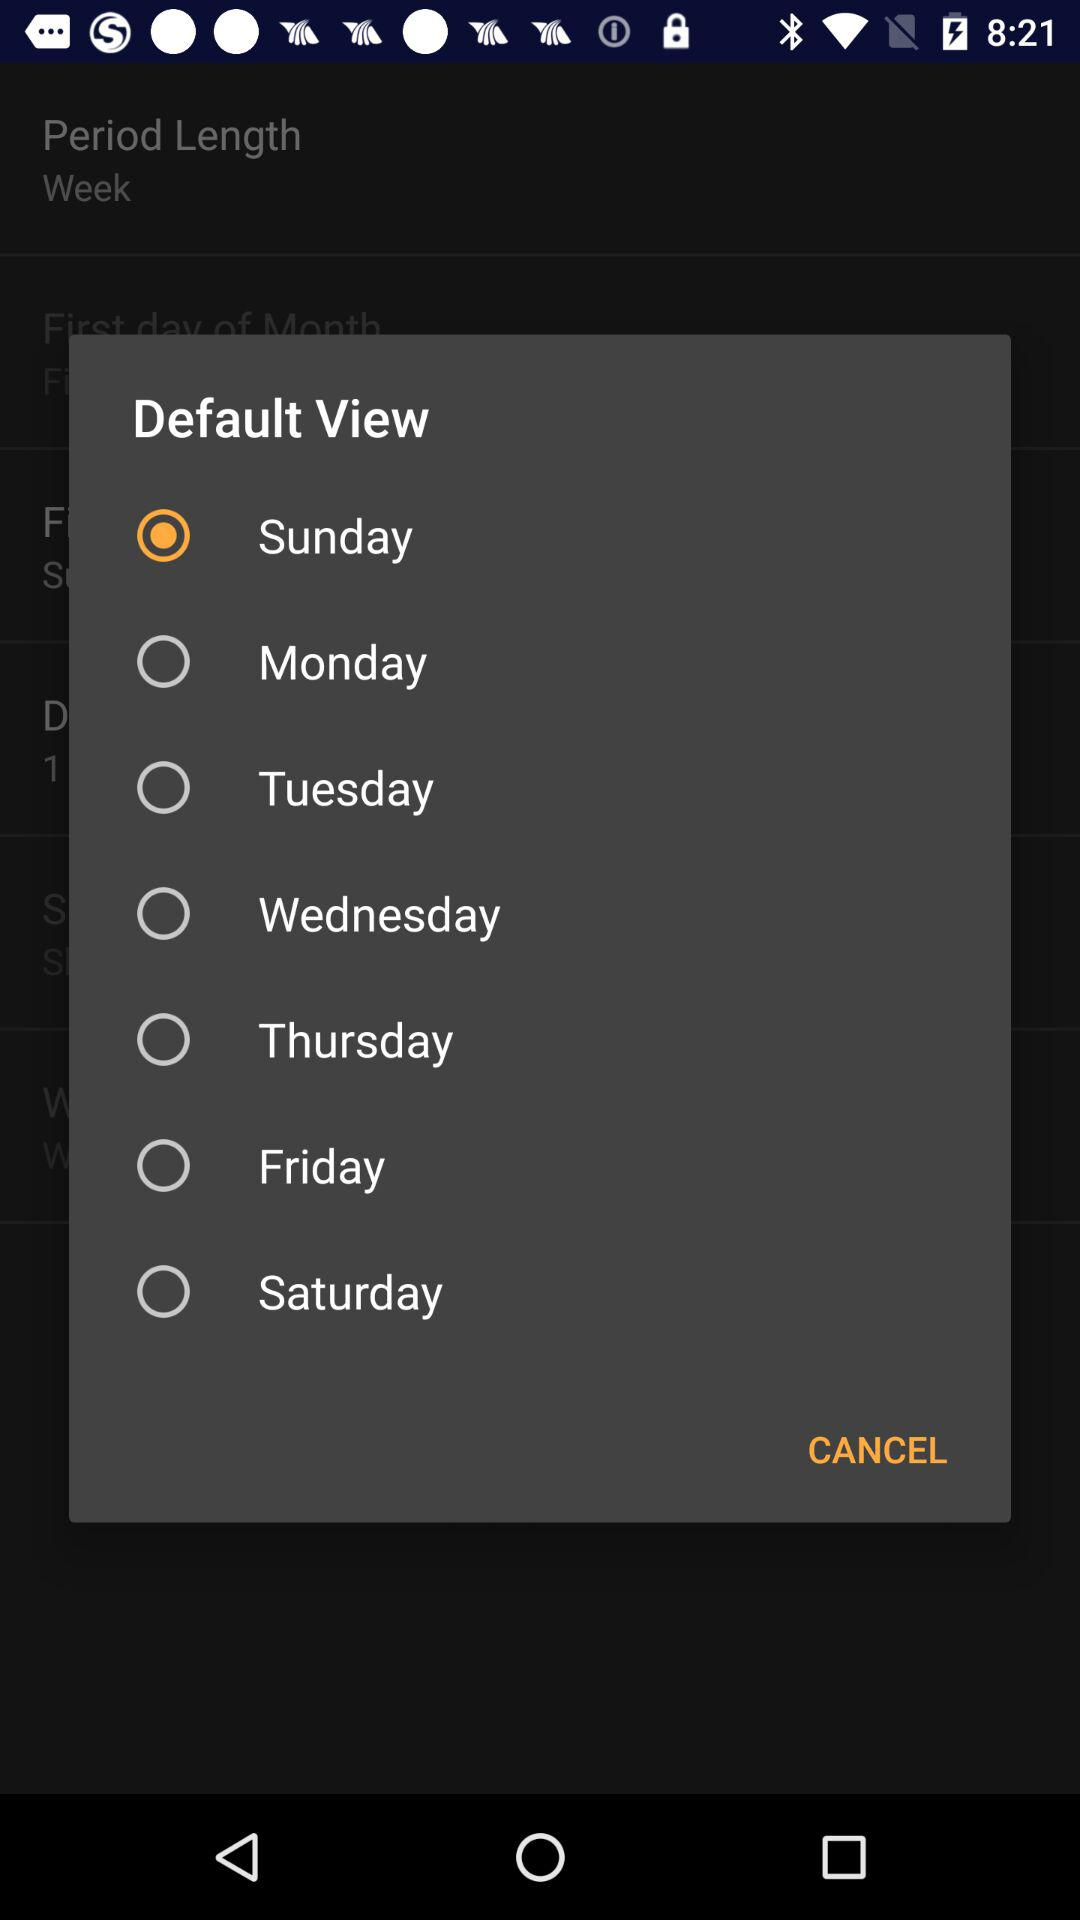What is the status of "Friday"? The status of "Friday" is "off". 